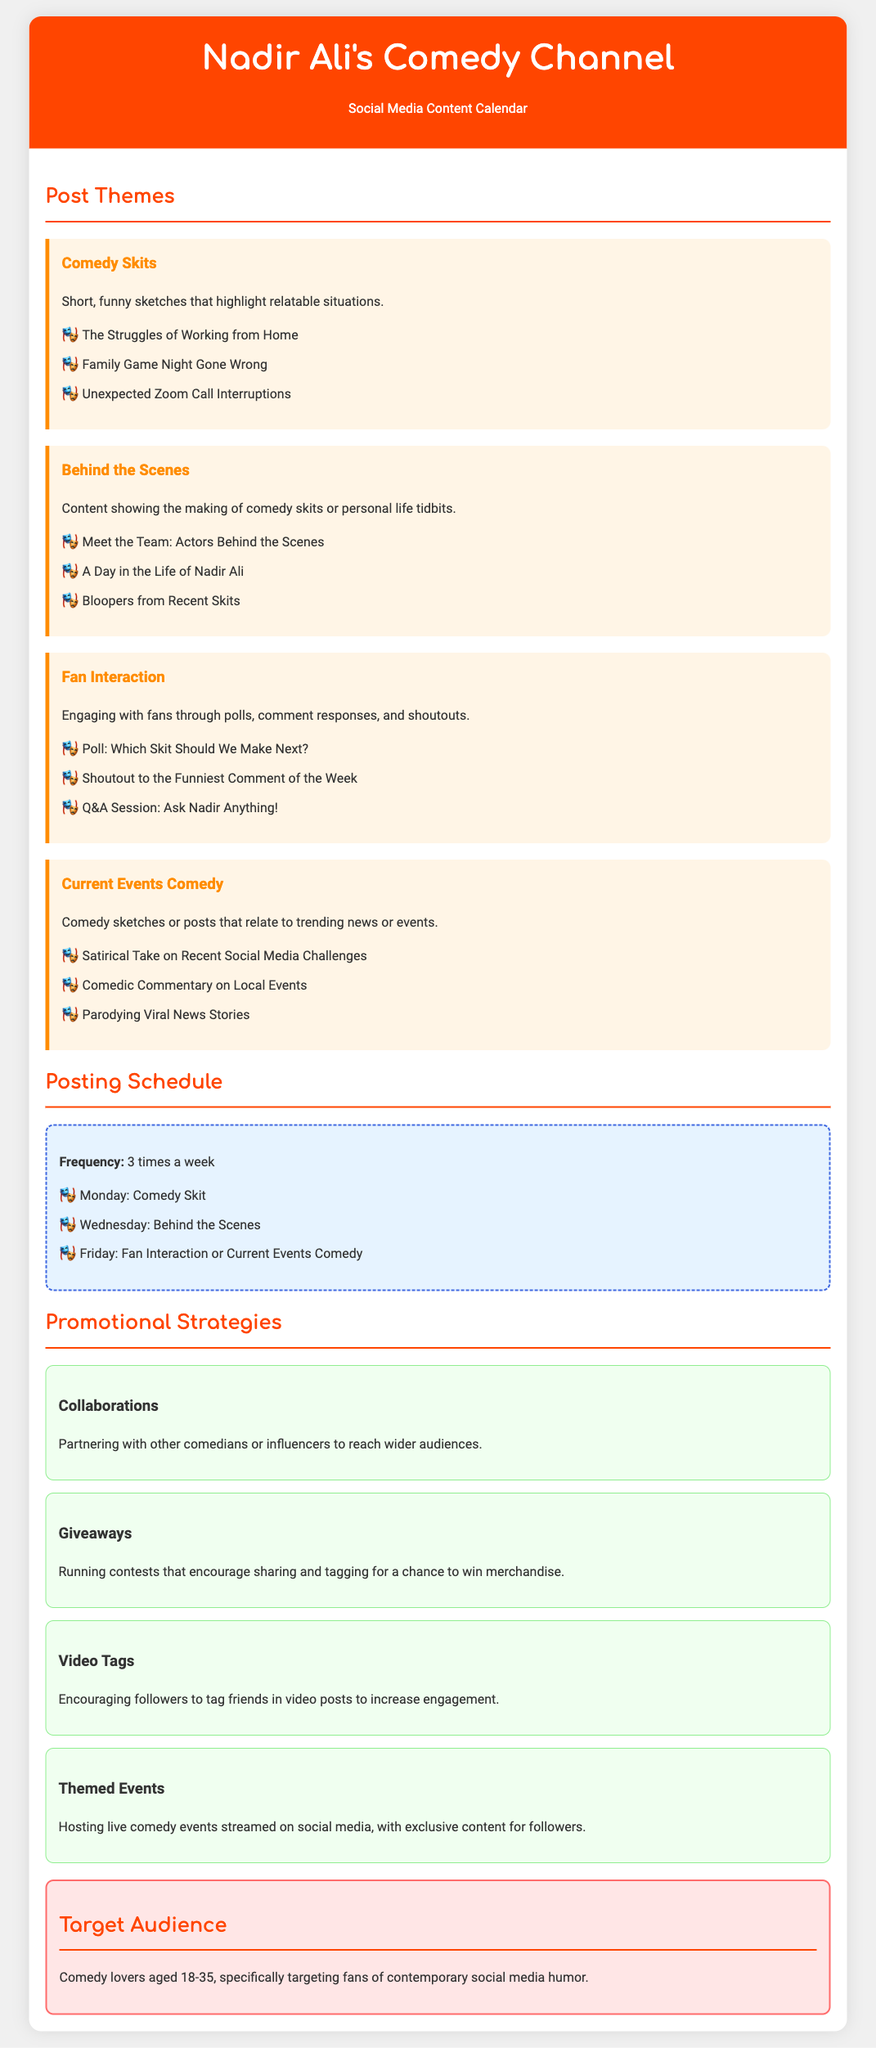what is the title of the document? The title of the document is stated in the header section, which is "Nadir Ali's Comedy Channel - Social Media Content Calendar."
Answer: Nadir Ali's Comedy Channel - Social Media Content Calendar how many times a week are posts scheduled? The frequency of posts is mentioned under the posting schedule section stating they are scheduled 3 times a week.
Answer: 3 times a week what is the first post theme listed? The first post theme is highlighted in the post themes section, which is "Comedy Skits."
Answer: Comedy Skits which day of the week is set for Fan Interaction or Current Events Comedy? The posting schedule specifies that Friday is set for Fan Interaction or Current Events Comedy.
Answer: Friday what is one of the strategies mentioned for promotion? The document lists several promotional strategies, one of which is "Collaborations."
Answer: Collaborations who is the target audience for Nadir Ali's Comedy Channel? The target audience is specified in the document as "Comedy lovers aged 18-35."
Answer: Comedy lovers aged 18-35 what type of content is included in "Behind the Scenes"? The section describes content showing the making of comedy skits or personal life tidbits as part of "Behind the Scenes."
Answer: Making of comedy skits or personal life tidbits how does the content calendar suggest engaging with fans? The "Fan Interaction" post theme suggests engaging with fans through polls, comment responses, and shoutouts.
Answer: Polls, comment responses, and shoutouts what color is the background of the promotional strategies section? The promotional strategies section background color is mentioned as light greenish, specifically described as "#F0FFF0" in the document.
Answer: Light greenish 